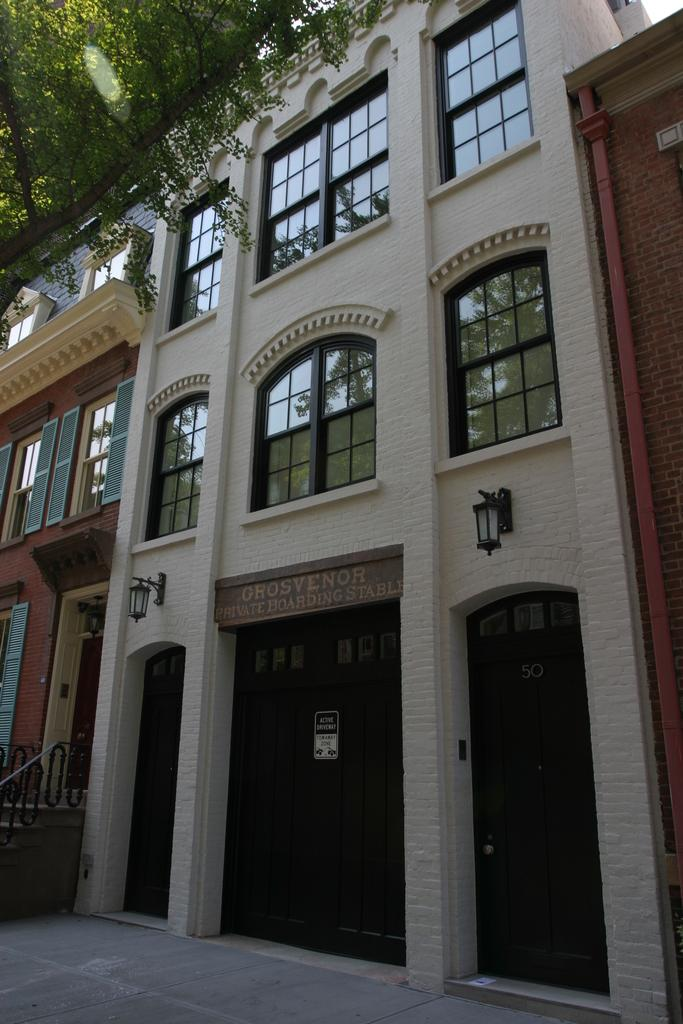What type of structure is present in the image? There is a building in the image. What feature can be observed on the building? The building has glass windows. What lighting fixtures are in front of the building? There are two black hanging lamps in front of the building. What is the color and type of the door on the front side of the building? There is a brown color door on the front side of the building. What type of voice can be heard coming from the building in the image? There is no indication of any voice or sound in the image, as it only shows the building and its features. 